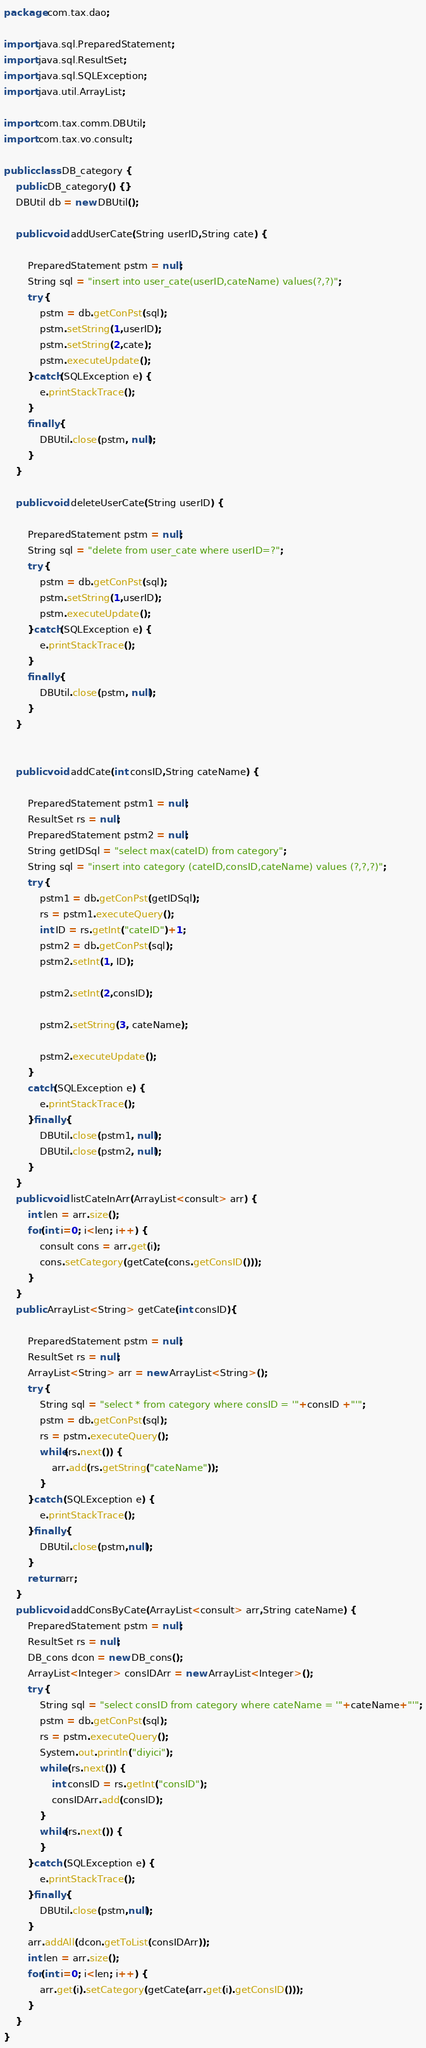<code> <loc_0><loc_0><loc_500><loc_500><_Java_>package com.tax.dao;

import java.sql.PreparedStatement;
import java.sql.ResultSet;
import java.sql.SQLException;
import java.util.ArrayList;

import com.tax.comm.DBUtil;
import com.tax.vo.consult;

public class DB_category {
	public DB_category() {}
	DBUtil db = new DBUtil();
	
	public void addUserCate(String userID,String cate) {

		PreparedStatement pstm = null;
		String sql = "insert into user_cate(userID,cateName) values(?,?)";
		try {
			pstm = db.getConPst(sql);
			pstm.setString(1,userID);
			pstm.setString(2,cate);
			pstm.executeUpdate();
		}catch(SQLException e) {
			e.printStackTrace();
		}
		finally {
			DBUtil.close(pstm, null);
		}
	}
	
	public void deleteUserCate(String userID) {

		PreparedStatement pstm = null;
		String sql = "delete from user_cate where userID=?";
		try {
			pstm = db.getConPst(sql);
			pstm.setString(1,userID);
			pstm.executeUpdate();
		}catch(SQLException e) {
			e.printStackTrace();
		}
		finally {
			DBUtil.close(pstm, null);
		}
	}
	
	
	public void addCate(int consID,String cateName) {

		PreparedStatement pstm1 = null;
		ResultSet rs = null;
		PreparedStatement pstm2 = null;
		String getIDSql = "select max(cateID) from category";
		String sql = "insert into category (cateID,consID,cateName) values (?,?,?)";
		try {
			pstm1 = db.getConPst(getIDSql);
			rs = pstm1.executeQuery();
			int ID = rs.getInt("cateID")+1;		
			pstm2 = db.getConPst(sql);
			pstm2.setInt(1, ID);			

			pstm2.setInt(2,consID);

			pstm2.setString(3, cateName);

			pstm2.executeUpdate();					
		}
		catch(SQLException e) {
			e.printStackTrace();
		}finally {
			DBUtil.close(pstm1, null);
			DBUtil.close(pstm2, null);
		}
	}
	public void listCateInArr(ArrayList<consult> arr) {
		int len = arr.size();
		for(int i=0; i<len; i++) {
			consult cons = arr.get(i);
			cons.setCategory(getCate(cons.getConsID()));
		}
	}
	public ArrayList<String> getCate(int consID){

		PreparedStatement pstm = null;
		ResultSet rs = null;
		ArrayList<String> arr = new ArrayList<String>();   
		try {
			String sql = "select * from category where consID = '"+consID +"'";
			pstm = db.getConPst(sql);
			rs = pstm.executeQuery();
			while(rs.next()) {
				arr.add(rs.getString("cateName"));
			}
		}catch (SQLException e) {
			e.printStackTrace();
		}finally {
			DBUtil.close(pstm,null);
		}
		return arr;
	}
	public void addConsByCate(ArrayList<consult> arr,String cateName) {
		PreparedStatement pstm = null;
		ResultSet rs = null;
		DB_cons dcon = new DB_cons();
		ArrayList<Integer> consIDArr = new ArrayList<Integer>();
		try {
			String sql = "select consID from category where cateName = '"+cateName+"'";
			pstm = db.getConPst(sql);
			rs = pstm.executeQuery();
			System.out.println("diyici");
			while (rs.next()) {
				int consID = rs.getInt("consID");
				consIDArr.add(consID);
			}
			while(rs.next()) {
			}
		}catch (SQLException e) {
			e.printStackTrace();
		}finally {
			DBUtil.close(pstm,null);
		}
		arr.addAll(dcon.getToList(consIDArr));
		int len = arr.size();
		for(int i=0; i<len; i++) {
			arr.get(i).setCategory(getCate(arr.get(i).getConsID()));
		}
	}
}
</code> 